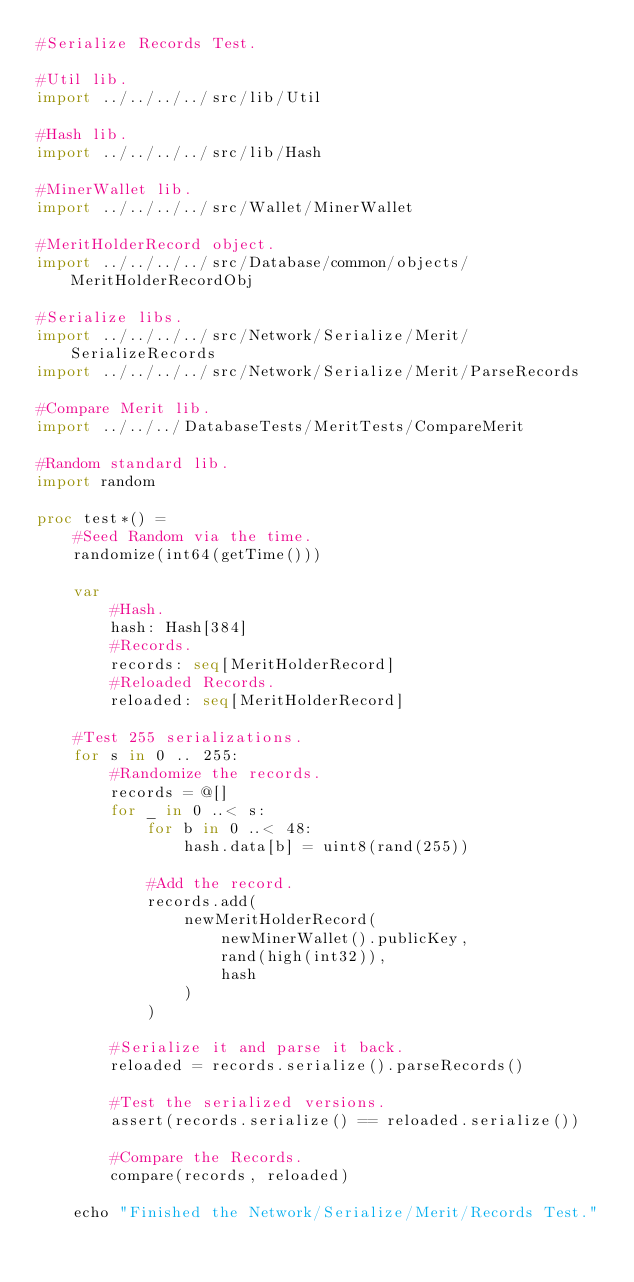<code> <loc_0><loc_0><loc_500><loc_500><_Nim_>#Serialize Records Test.

#Util lib.
import ../../../../src/lib/Util

#Hash lib.
import ../../../../src/lib/Hash

#MinerWallet lib.
import ../../../../src/Wallet/MinerWallet

#MeritHolderRecord object.
import ../../../../src/Database/common/objects/MeritHolderRecordObj

#Serialize libs.
import ../../../../src/Network/Serialize/Merit/SerializeRecords
import ../../../../src/Network/Serialize/Merit/ParseRecords

#Compare Merit lib.
import ../../../DatabaseTests/MeritTests/CompareMerit

#Random standard lib.
import random

proc test*() =
    #Seed Random via the time.
    randomize(int64(getTime()))

    var
        #Hash.
        hash: Hash[384]
        #Records.
        records: seq[MeritHolderRecord]
        #Reloaded Records.
        reloaded: seq[MeritHolderRecord]

    #Test 255 serializations.
    for s in 0 .. 255:
        #Randomize the records.
        records = @[]
        for _ in 0 ..< s:
            for b in 0 ..< 48:
                hash.data[b] = uint8(rand(255))

            #Add the record.
            records.add(
                newMeritHolderRecord(
                    newMinerWallet().publicKey,
                    rand(high(int32)),
                    hash
                )
            )

        #Serialize it and parse it back.
        reloaded = records.serialize().parseRecords()

        #Test the serialized versions.
        assert(records.serialize() == reloaded.serialize())

        #Compare the Records.
        compare(records, reloaded)

    echo "Finished the Network/Serialize/Merit/Records Test."
</code> 